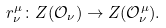Convert formula to latex. <formula><loc_0><loc_0><loc_500><loc_500>r ^ { \mu } _ { \nu } \colon Z ( \mathcal { O } _ { \nu } ) \rightarrow Z ( \mathcal { O } ^ { \mu } _ { \nu } ) .</formula> 